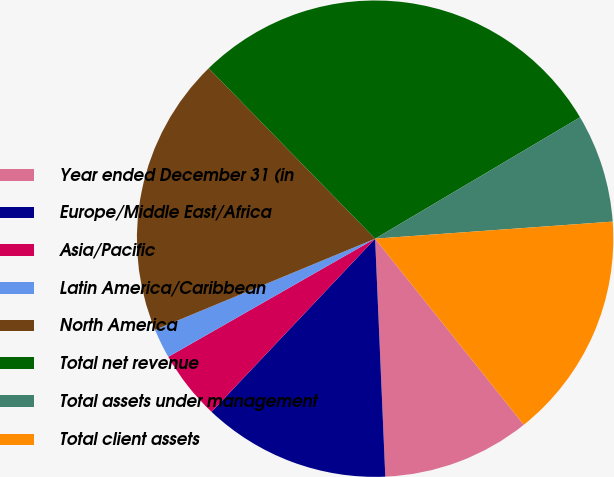Convert chart. <chart><loc_0><loc_0><loc_500><loc_500><pie_chart><fcel>Year ended December 31 (in<fcel>Europe/Middle East/Africa<fcel>Asia/Pacific<fcel>Latin America/Caribbean<fcel>North America<fcel>Total net revenue<fcel>Total assets under management<fcel>Total client assets<nl><fcel>10.05%<fcel>12.73%<fcel>4.69%<fcel>2.01%<fcel>18.94%<fcel>28.8%<fcel>7.37%<fcel>15.41%<nl></chart> 